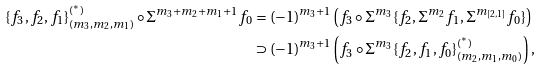<formula> <loc_0><loc_0><loc_500><loc_500>\{ f _ { 3 } , f _ { 2 } , f _ { 1 } \} ^ { ( ^ { * } ) } _ { ( m _ { 3 } , m _ { 2 } , m _ { 1 } ) } \circ \Sigma ^ { m _ { 3 } + m _ { 2 } + m _ { 1 } + 1 } f _ { 0 } & = ( - 1 ) ^ { m _ { 3 } + 1 } \left ( f _ { 3 } \circ \Sigma ^ { m _ { 3 } } \{ f _ { 2 } , \Sigma ^ { m _ { 2 } } f _ { 1 } , \Sigma ^ { m _ { [ 2 , 1 ] } } f _ { 0 } \} \right ) \\ & \supset ( - 1 ) ^ { m _ { 3 } + 1 } \left ( f _ { 3 } \circ \Sigma ^ { m _ { 3 } } \{ f _ { 2 } , f _ { 1 } , f _ { 0 } \} ^ { ( ^ { * } ) } _ { ( m _ { 2 } , m _ { 1 } , m _ { 0 } ) } \right ) ,</formula> 